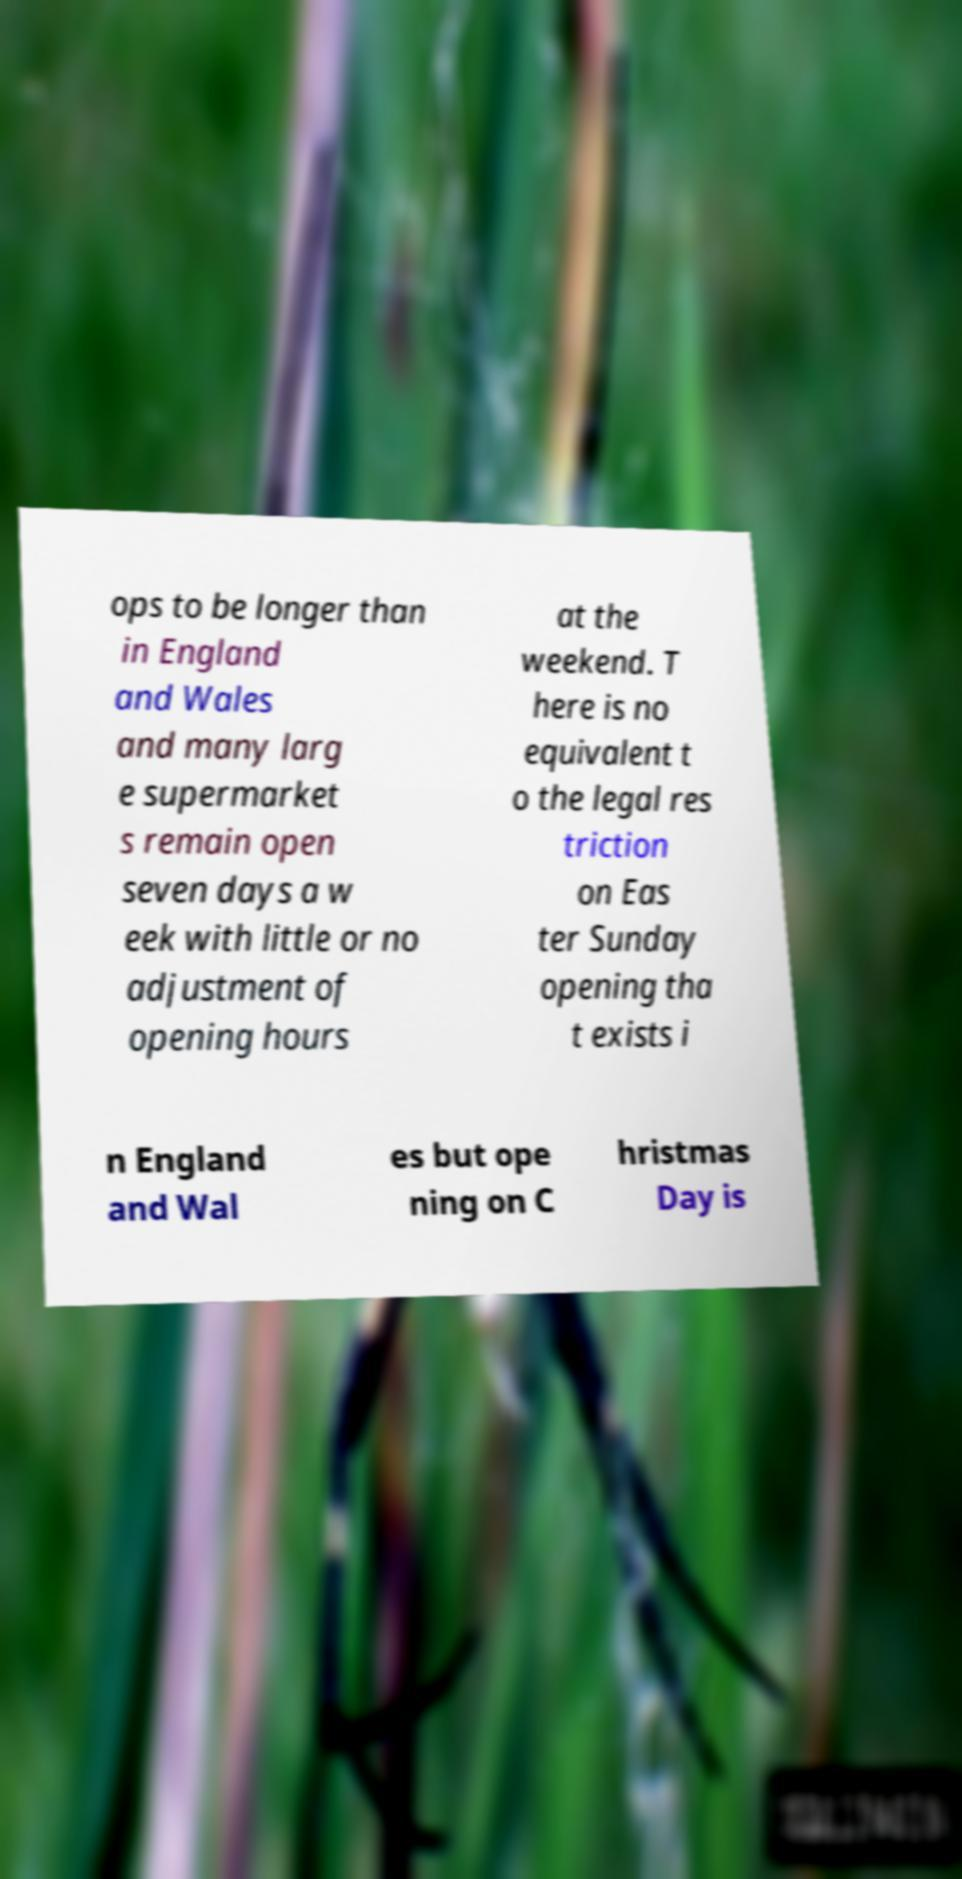There's text embedded in this image that I need extracted. Can you transcribe it verbatim? ops to be longer than in England and Wales and many larg e supermarket s remain open seven days a w eek with little or no adjustment of opening hours at the weekend. T here is no equivalent t o the legal res triction on Eas ter Sunday opening tha t exists i n England and Wal es but ope ning on C hristmas Day is 